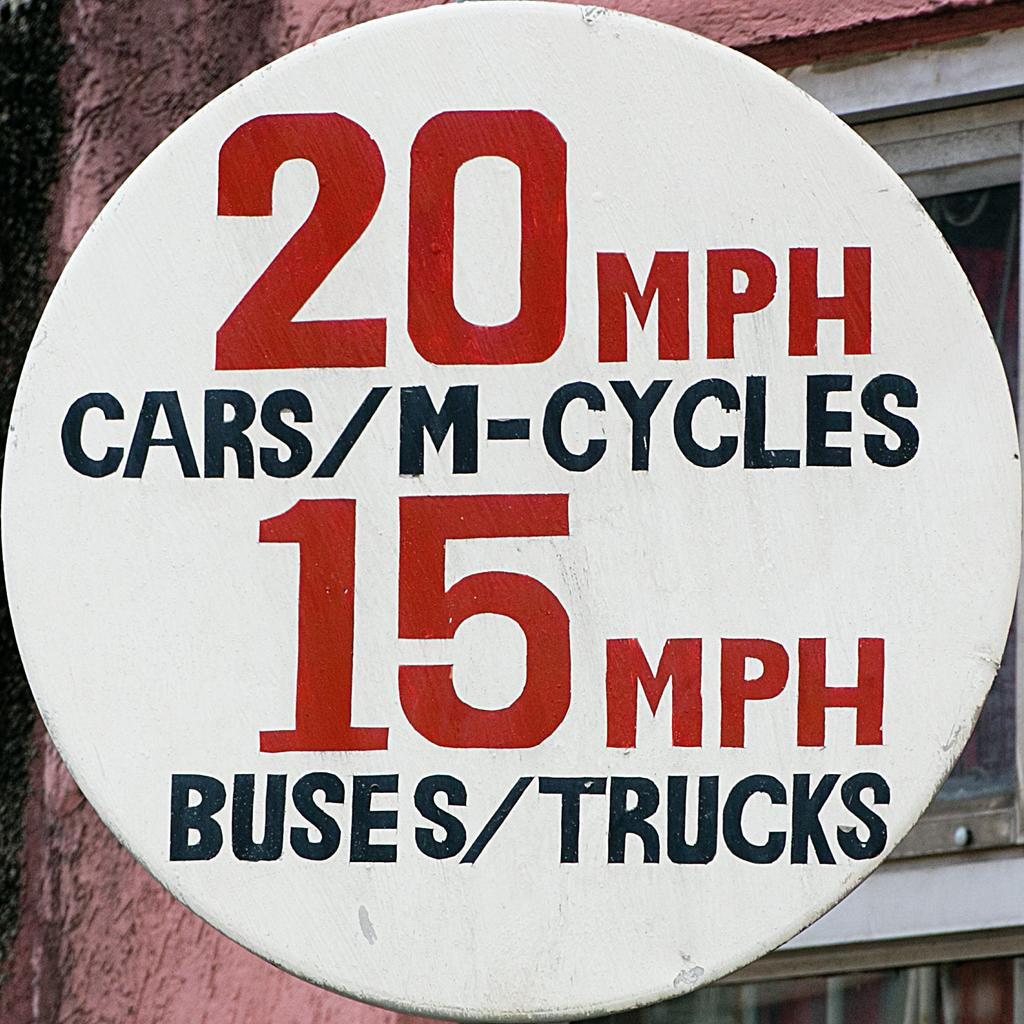<image>
Relay a brief, clear account of the picture shown. A speed sign gives 20MPH to cars and cycles, and 15mph to buses and trucks. 